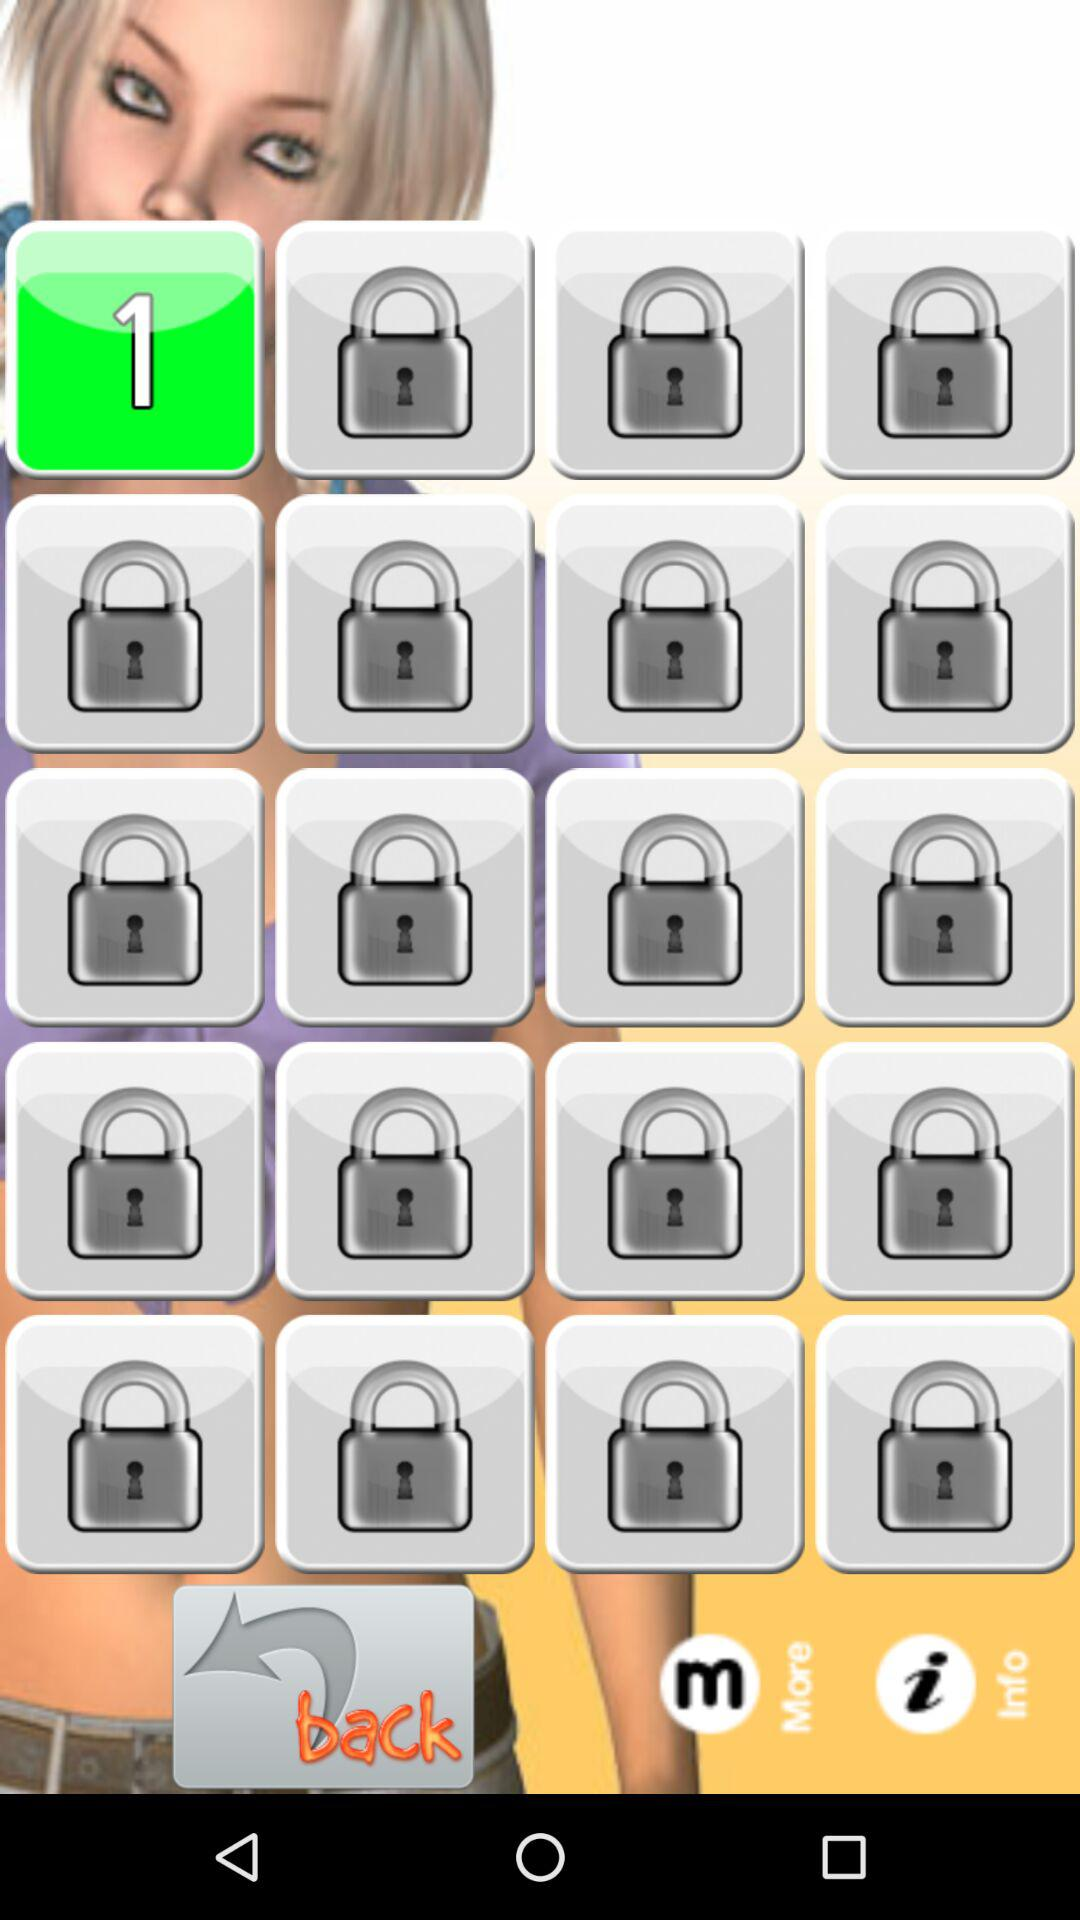On which level is the person? The person is on the first level. 